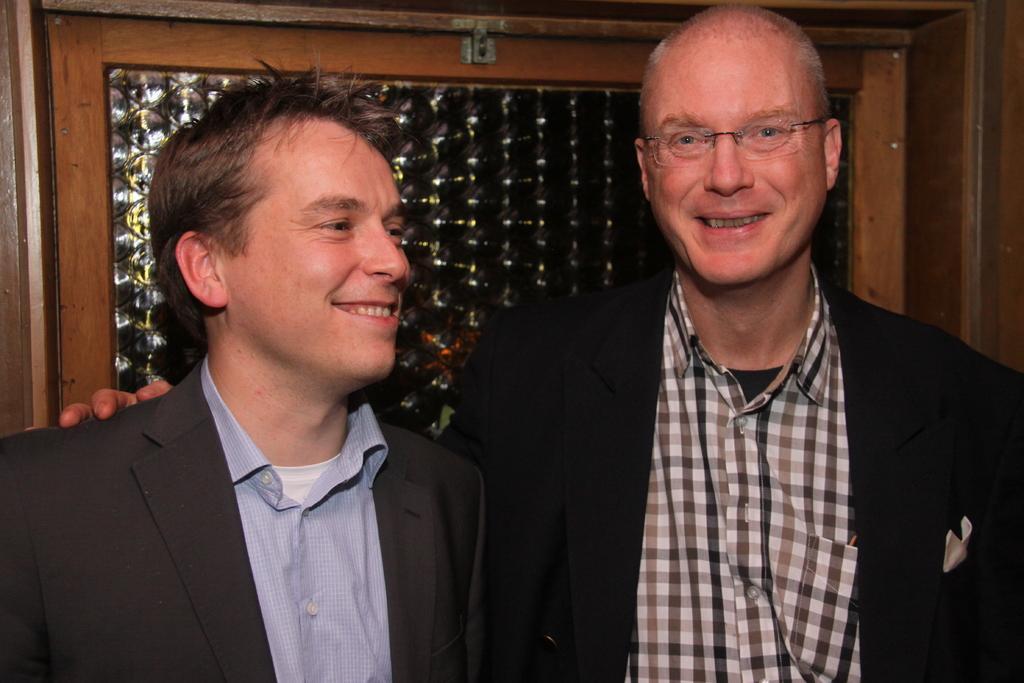Please provide a concise description of this image. In this image, we can see two persons wearing clothes. 